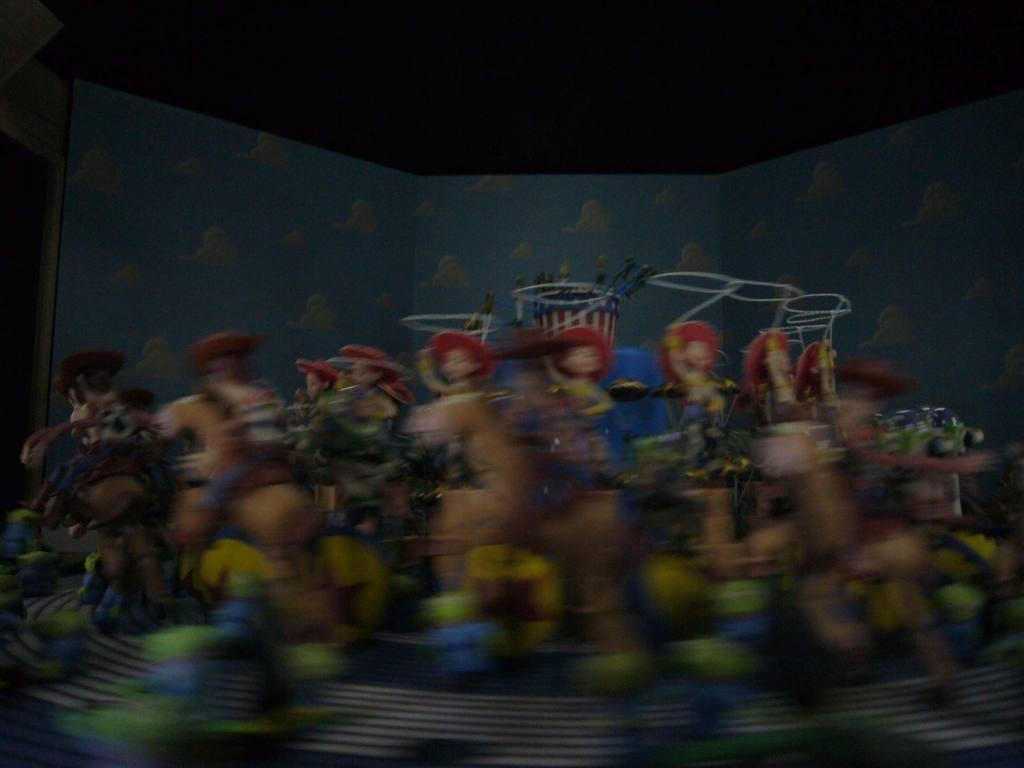Could you give a brief overview of what you see in this image? In this image I can see few toys and the background is in blue and black color. The image is blurred. 